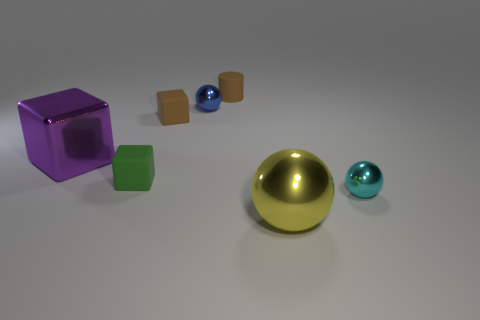Add 1 tiny brown matte things. How many objects exist? 8 Subtract all balls. How many objects are left? 4 Subtract all big purple metallic things. Subtract all rubber objects. How many objects are left? 3 Add 3 small green matte blocks. How many small green matte blocks are left? 4 Add 2 blue spheres. How many blue spheres exist? 3 Subtract 1 brown cylinders. How many objects are left? 6 